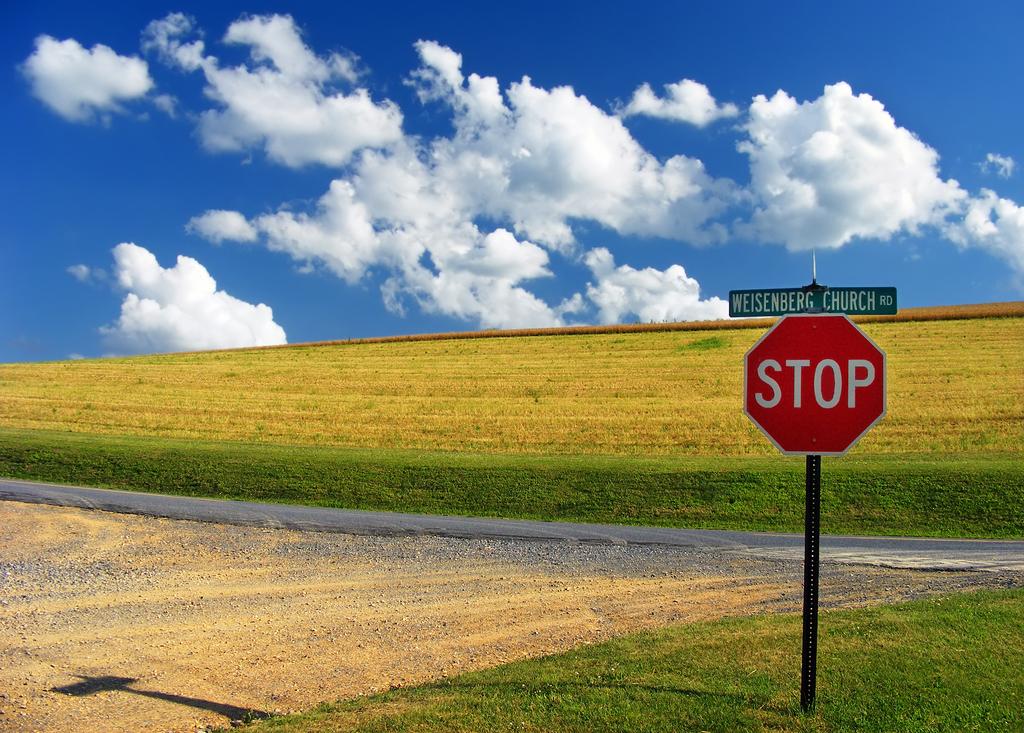What is one of the roads mentioned?
Keep it short and to the point. Weisenberg church rd. What is the name of this street?
Your answer should be very brief. Weisenberg church rd. 